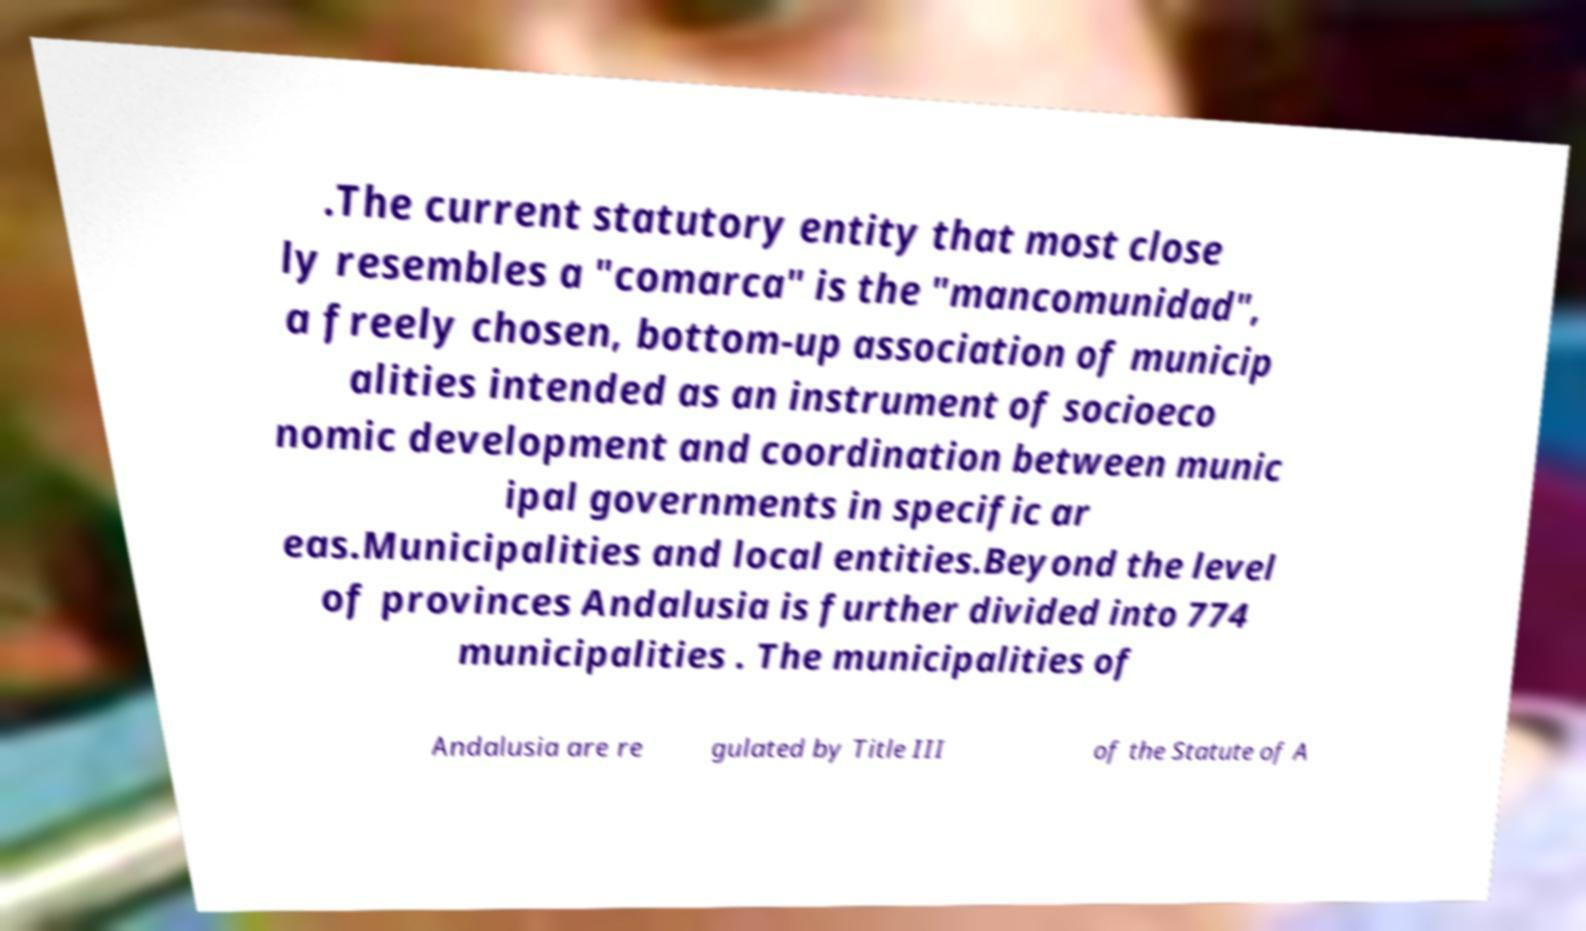Please read and relay the text visible in this image. What does it say? .The current statutory entity that most close ly resembles a "comarca" is the "mancomunidad", a freely chosen, bottom-up association of municip alities intended as an instrument of socioeco nomic development and coordination between munic ipal governments in specific ar eas.Municipalities and local entities.Beyond the level of provinces Andalusia is further divided into 774 municipalities . The municipalities of Andalusia are re gulated by Title III of the Statute of A 